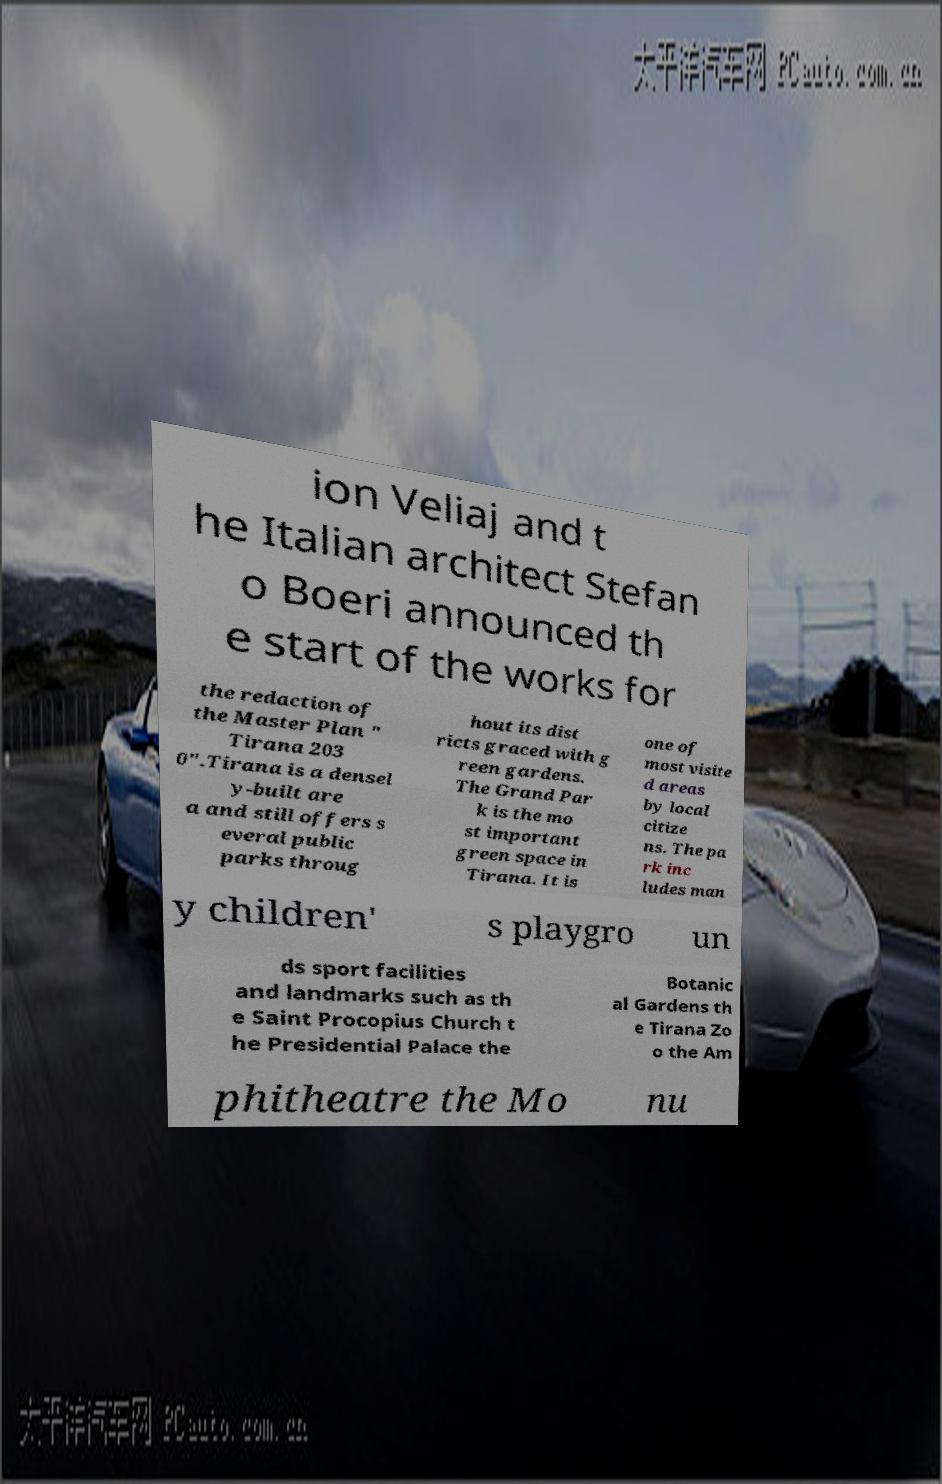What messages or text are displayed in this image? I need them in a readable, typed format. ion Veliaj and t he Italian architect Stefan o Boeri announced th e start of the works for the redaction of the Master Plan " Tirana 203 0".Tirana is a densel y-built are a and still offers s everal public parks throug hout its dist ricts graced with g reen gardens. The Grand Par k is the mo st important green space in Tirana. It is one of most visite d areas by local citize ns. The pa rk inc ludes man y children' s playgro un ds sport facilities and landmarks such as th e Saint Procopius Church t he Presidential Palace the Botanic al Gardens th e Tirana Zo o the Am phitheatre the Mo nu 